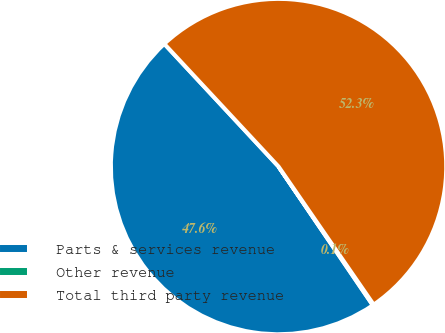Convert chart. <chart><loc_0><loc_0><loc_500><loc_500><pie_chart><fcel>Parts & services revenue<fcel>Other revenue<fcel>Total third party revenue<nl><fcel>47.57%<fcel>0.1%<fcel>52.33%<nl></chart> 